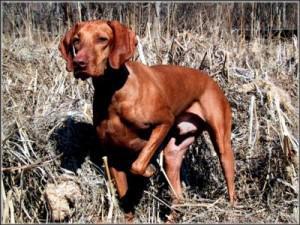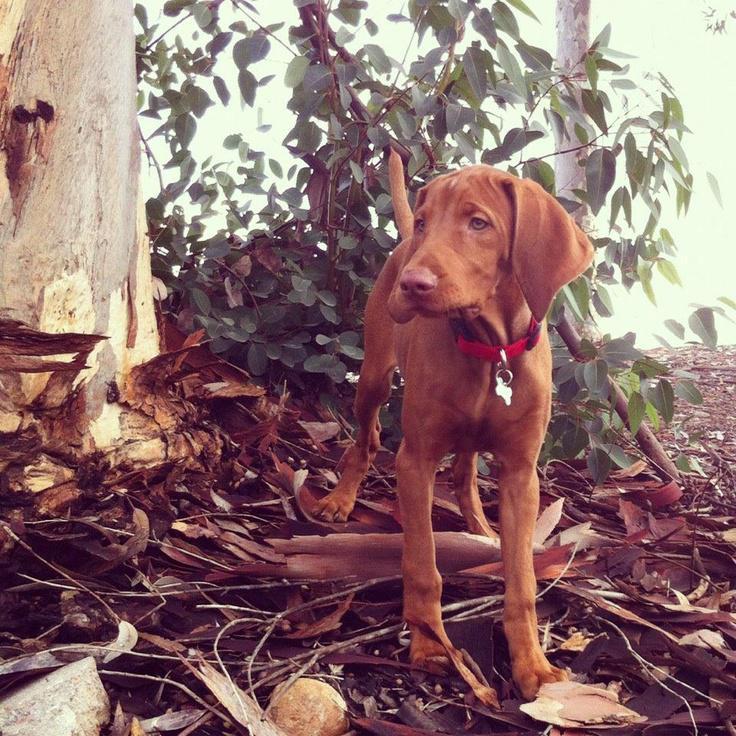The first image is the image on the left, the second image is the image on the right. Given the left and right images, does the statement "The dog in the image on the left is standing up outside." hold true? Answer yes or no. Yes. The first image is the image on the left, the second image is the image on the right. Evaluate the accuracy of this statement regarding the images: "In one image, a dog's upright head and shoulders are behind a squarish flat surface which its front paws are over.". Is it true? Answer yes or no. No. 